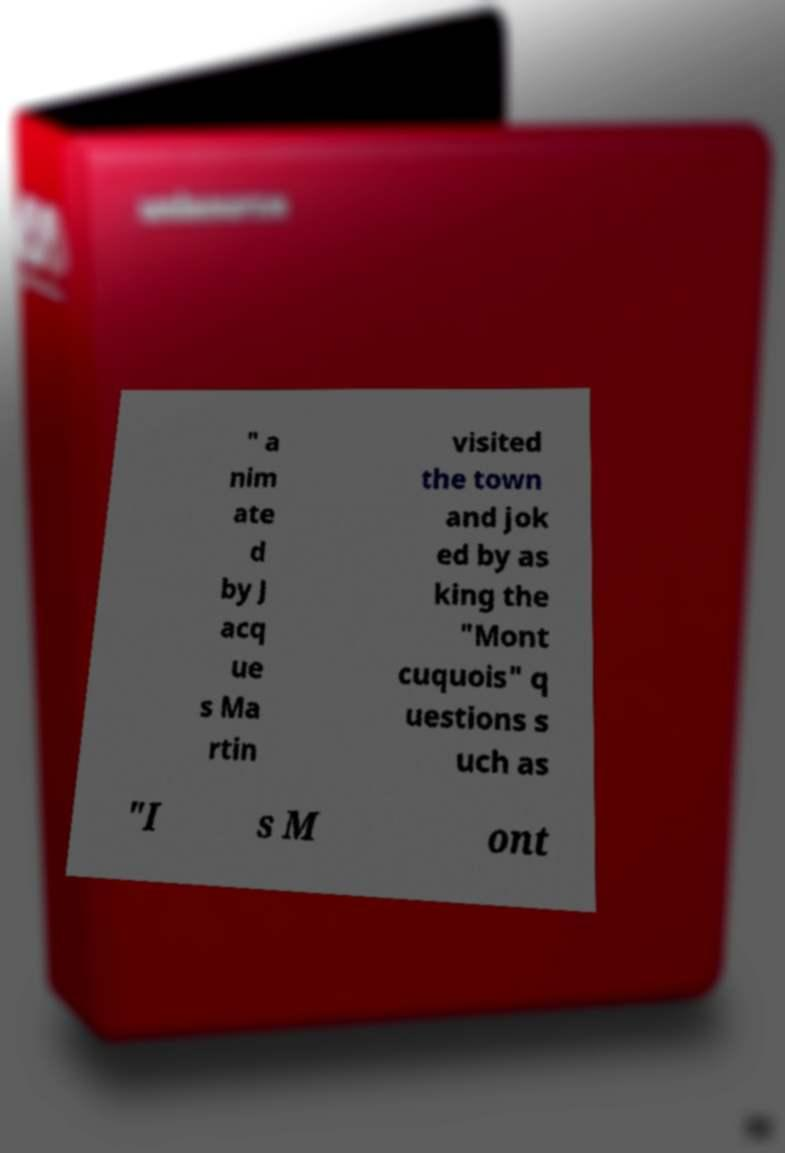I need the written content from this picture converted into text. Can you do that? " a nim ate d by J acq ue s Ma rtin visited the town and jok ed by as king the "Mont cuquois" q uestions s uch as "I s M ont 